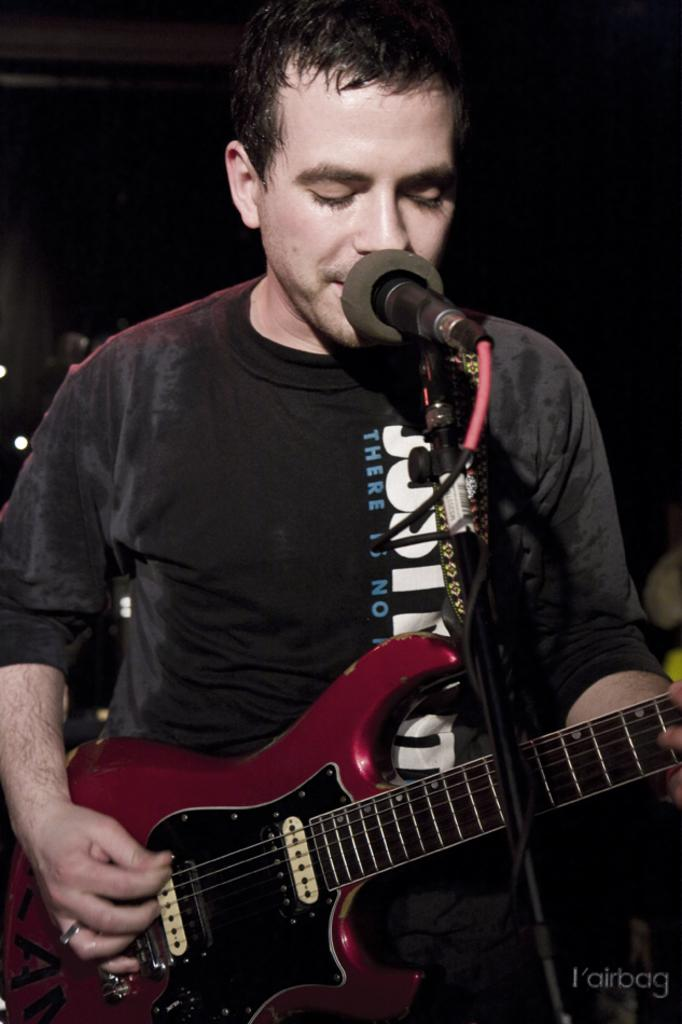What is the main subject of the image? The main subject of the image is a man. Where is the man positioned in the image? The man is standing in the center of the image. What is the man doing in the image? The man is playing a guitar and singing on a microphone. What type of creature is playing with dolls in the image? There is no creature or dolls present in the image; it features a man playing a guitar and singing on a microphone. What is the man using to whip the audience in the image? There is no whip or audience present in the image; it only shows a man playing a guitar and singing on a microphone. 